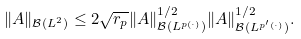Convert formula to latex. <formula><loc_0><loc_0><loc_500><loc_500>\| A \| _ { \mathcal { B } ( L ^ { 2 } ) } \leq 2 \sqrt { r _ { p } } \| A \| _ { \mathcal { B } ( L ^ { p ( \cdot ) } ) } ^ { 1 / 2 } \| A \| _ { \mathcal { B } ( L ^ { p ^ { \prime } ( \cdot ) } ) } ^ { 1 / 2 } .</formula> 